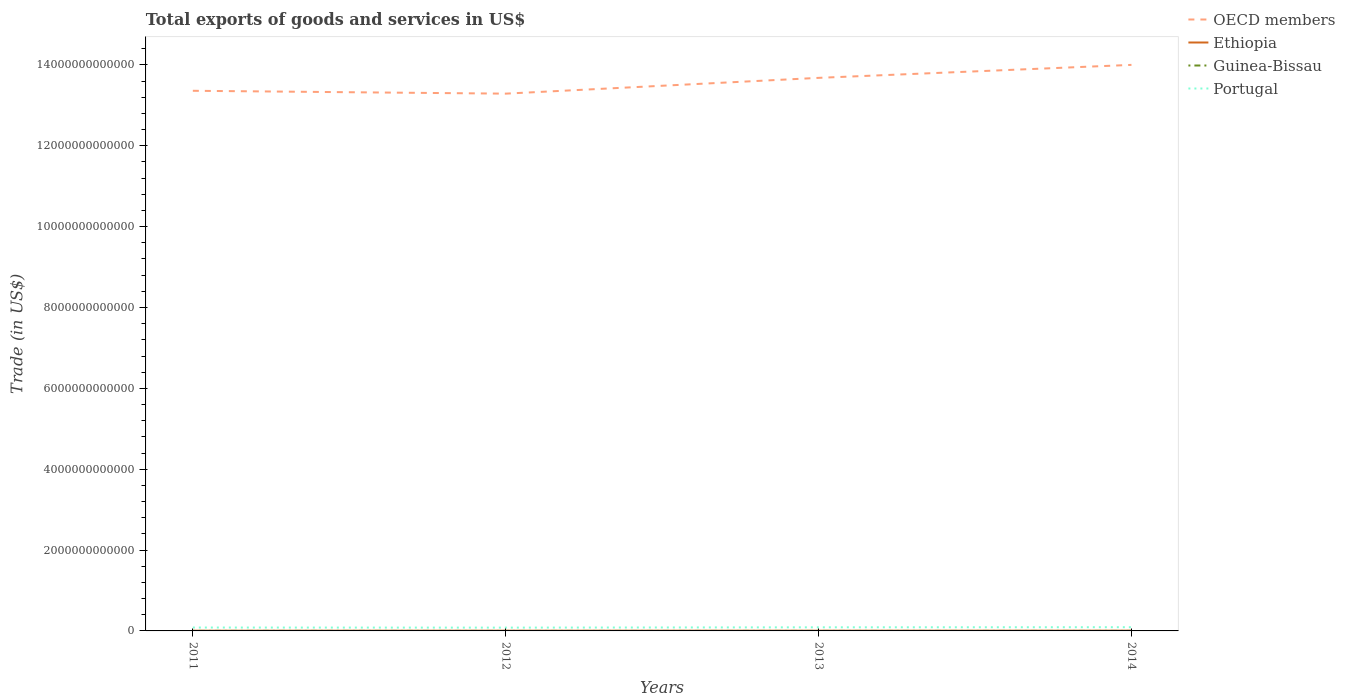Does the line corresponding to OECD members intersect with the line corresponding to Ethiopia?
Your response must be concise. No. Across all years, what is the maximum total exports of goods and services in Portugal?
Offer a terse response. 8.16e+1. What is the total total exports of goods and services in Guinea-Bissau in the graph?
Offer a very short reply. -2.21e+07. What is the difference between the highest and the second highest total exports of goods and services in Ethiopia?
Your answer should be very brief. 1.14e+09. How many lines are there?
Your response must be concise. 4. How many years are there in the graph?
Your answer should be very brief. 4. What is the difference between two consecutive major ticks on the Y-axis?
Make the answer very short. 2.00e+12. Are the values on the major ticks of Y-axis written in scientific E-notation?
Ensure brevity in your answer.  No. Does the graph contain any zero values?
Your answer should be compact. No. Where does the legend appear in the graph?
Your answer should be very brief. Top right. How are the legend labels stacked?
Offer a terse response. Vertical. What is the title of the graph?
Your answer should be compact. Total exports of goods and services in US$. What is the label or title of the Y-axis?
Provide a succinct answer. Trade (in US$). What is the Trade (in US$) in OECD members in 2011?
Give a very brief answer. 1.34e+13. What is the Trade (in US$) in Ethiopia in 2011?
Your answer should be very brief. 5.33e+09. What is the Trade (in US$) of Guinea-Bissau in 2011?
Provide a succinct answer. 2.96e+08. What is the Trade (in US$) of Portugal in 2011?
Ensure brevity in your answer.  8.40e+1. What is the Trade (in US$) of OECD members in 2012?
Your answer should be very brief. 1.33e+13. What is the Trade (in US$) in Ethiopia in 2012?
Offer a very short reply. 5.96e+09. What is the Trade (in US$) in Guinea-Bissau in 2012?
Your response must be concise. 1.43e+08. What is the Trade (in US$) of Portugal in 2012?
Your answer should be very brief. 8.16e+1. What is the Trade (in US$) in OECD members in 2013?
Your answer should be very brief. 1.37e+13. What is the Trade (in US$) in Ethiopia in 2013?
Provide a succinct answer. 5.95e+09. What is the Trade (in US$) of Guinea-Bissau in 2013?
Your response must be concise. 1.65e+08. What is the Trade (in US$) of Portugal in 2013?
Provide a succinct answer. 8.93e+1. What is the Trade (in US$) in OECD members in 2014?
Offer a very short reply. 1.40e+13. What is the Trade (in US$) in Ethiopia in 2014?
Offer a very short reply. 6.47e+09. What is the Trade (in US$) in Guinea-Bissau in 2014?
Your answer should be compact. 1.68e+08. What is the Trade (in US$) in Portugal in 2014?
Provide a succinct answer. 9.21e+1. Across all years, what is the maximum Trade (in US$) in OECD members?
Keep it short and to the point. 1.40e+13. Across all years, what is the maximum Trade (in US$) in Ethiopia?
Your answer should be compact. 6.47e+09. Across all years, what is the maximum Trade (in US$) in Guinea-Bissau?
Give a very brief answer. 2.96e+08. Across all years, what is the maximum Trade (in US$) of Portugal?
Offer a very short reply. 9.21e+1. Across all years, what is the minimum Trade (in US$) of OECD members?
Your response must be concise. 1.33e+13. Across all years, what is the minimum Trade (in US$) of Ethiopia?
Offer a very short reply. 5.33e+09. Across all years, what is the minimum Trade (in US$) in Guinea-Bissau?
Give a very brief answer. 1.43e+08. Across all years, what is the minimum Trade (in US$) of Portugal?
Your answer should be compact. 8.16e+1. What is the total Trade (in US$) in OECD members in the graph?
Offer a very short reply. 5.43e+13. What is the total Trade (in US$) of Ethiopia in the graph?
Keep it short and to the point. 2.37e+1. What is the total Trade (in US$) of Guinea-Bissau in the graph?
Keep it short and to the point. 7.73e+08. What is the total Trade (in US$) in Portugal in the graph?
Offer a terse response. 3.47e+11. What is the difference between the Trade (in US$) of OECD members in 2011 and that in 2012?
Keep it short and to the point. 7.06e+1. What is the difference between the Trade (in US$) of Ethiopia in 2011 and that in 2012?
Your answer should be very brief. -6.31e+08. What is the difference between the Trade (in US$) in Guinea-Bissau in 2011 and that in 2012?
Your response must be concise. 1.53e+08. What is the difference between the Trade (in US$) of Portugal in 2011 and that in 2012?
Your answer should be very brief. 2.38e+09. What is the difference between the Trade (in US$) in OECD members in 2011 and that in 2013?
Ensure brevity in your answer.  -3.20e+11. What is the difference between the Trade (in US$) of Ethiopia in 2011 and that in 2013?
Provide a succinct answer. -6.17e+08. What is the difference between the Trade (in US$) of Guinea-Bissau in 2011 and that in 2013?
Provide a succinct answer. 1.30e+08. What is the difference between the Trade (in US$) in Portugal in 2011 and that in 2013?
Keep it short and to the point. -5.36e+09. What is the difference between the Trade (in US$) in OECD members in 2011 and that in 2014?
Your answer should be compact. -6.41e+11. What is the difference between the Trade (in US$) of Ethiopia in 2011 and that in 2014?
Give a very brief answer. -1.14e+09. What is the difference between the Trade (in US$) of Guinea-Bissau in 2011 and that in 2014?
Keep it short and to the point. 1.28e+08. What is the difference between the Trade (in US$) in Portugal in 2011 and that in 2014?
Ensure brevity in your answer.  -8.18e+09. What is the difference between the Trade (in US$) in OECD members in 2012 and that in 2013?
Provide a succinct answer. -3.91e+11. What is the difference between the Trade (in US$) of Ethiopia in 2012 and that in 2013?
Ensure brevity in your answer.  1.43e+07. What is the difference between the Trade (in US$) of Guinea-Bissau in 2012 and that in 2013?
Provide a succinct answer. -2.21e+07. What is the difference between the Trade (in US$) of Portugal in 2012 and that in 2013?
Ensure brevity in your answer.  -7.74e+09. What is the difference between the Trade (in US$) of OECD members in 2012 and that in 2014?
Your response must be concise. -7.12e+11. What is the difference between the Trade (in US$) of Ethiopia in 2012 and that in 2014?
Provide a short and direct response. -5.11e+08. What is the difference between the Trade (in US$) in Guinea-Bissau in 2012 and that in 2014?
Offer a terse response. -2.49e+07. What is the difference between the Trade (in US$) of Portugal in 2012 and that in 2014?
Your answer should be very brief. -1.06e+1. What is the difference between the Trade (in US$) in OECD members in 2013 and that in 2014?
Your response must be concise. -3.21e+11. What is the difference between the Trade (in US$) in Ethiopia in 2013 and that in 2014?
Your answer should be very brief. -5.26e+08. What is the difference between the Trade (in US$) of Guinea-Bissau in 2013 and that in 2014?
Provide a short and direct response. -2.83e+06. What is the difference between the Trade (in US$) of Portugal in 2013 and that in 2014?
Provide a succinct answer. -2.81e+09. What is the difference between the Trade (in US$) of OECD members in 2011 and the Trade (in US$) of Ethiopia in 2012?
Give a very brief answer. 1.34e+13. What is the difference between the Trade (in US$) in OECD members in 2011 and the Trade (in US$) in Guinea-Bissau in 2012?
Keep it short and to the point. 1.34e+13. What is the difference between the Trade (in US$) in OECD members in 2011 and the Trade (in US$) in Portugal in 2012?
Your answer should be compact. 1.33e+13. What is the difference between the Trade (in US$) of Ethiopia in 2011 and the Trade (in US$) of Guinea-Bissau in 2012?
Give a very brief answer. 5.19e+09. What is the difference between the Trade (in US$) in Ethiopia in 2011 and the Trade (in US$) in Portugal in 2012?
Ensure brevity in your answer.  -7.63e+1. What is the difference between the Trade (in US$) in Guinea-Bissau in 2011 and the Trade (in US$) in Portugal in 2012?
Give a very brief answer. -8.13e+1. What is the difference between the Trade (in US$) of OECD members in 2011 and the Trade (in US$) of Ethiopia in 2013?
Make the answer very short. 1.34e+13. What is the difference between the Trade (in US$) of OECD members in 2011 and the Trade (in US$) of Guinea-Bissau in 2013?
Ensure brevity in your answer.  1.34e+13. What is the difference between the Trade (in US$) in OECD members in 2011 and the Trade (in US$) in Portugal in 2013?
Make the answer very short. 1.33e+13. What is the difference between the Trade (in US$) of Ethiopia in 2011 and the Trade (in US$) of Guinea-Bissau in 2013?
Your answer should be compact. 5.17e+09. What is the difference between the Trade (in US$) in Ethiopia in 2011 and the Trade (in US$) in Portugal in 2013?
Provide a succinct answer. -8.40e+1. What is the difference between the Trade (in US$) in Guinea-Bissau in 2011 and the Trade (in US$) in Portugal in 2013?
Your response must be concise. -8.90e+1. What is the difference between the Trade (in US$) of OECD members in 2011 and the Trade (in US$) of Ethiopia in 2014?
Provide a short and direct response. 1.34e+13. What is the difference between the Trade (in US$) of OECD members in 2011 and the Trade (in US$) of Guinea-Bissau in 2014?
Provide a short and direct response. 1.34e+13. What is the difference between the Trade (in US$) of OECD members in 2011 and the Trade (in US$) of Portugal in 2014?
Ensure brevity in your answer.  1.33e+13. What is the difference between the Trade (in US$) in Ethiopia in 2011 and the Trade (in US$) in Guinea-Bissau in 2014?
Your response must be concise. 5.16e+09. What is the difference between the Trade (in US$) of Ethiopia in 2011 and the Trade (in US$) of Portugal in 2014?
Your answer should be compact. -8.68e+1. What is the difference between the Trade (in US$) of Guinea-Bissau in 2011 and the Trade (in US$) of Portugal in 2014?
Your response must be concise. -9.19e+1. What is the difference between the Trade (in US$) in OECD members in 2012 and the Trade (in US$) in Ethiopia in 2013?
Provide a succinct answer. 1.33e+13. What is the difference between the Trade (in US$) in OECD members in 2012 and the Trade (in US$) in Guinea-Bissau in 2013?
Make the answer very short. 1.33e+13. What is the difference between the Trade (in US$) in OECD members in 2012 and the Trade (in US$) in Portugal in 2013?
Provide a succinct answer. 1.32e+13. What is the difference between the Trade (in US$) in Ethiopia in 2012 and the Trade (in US$) in Guinea-Bissau in 2013?
Your answer should be very brief. 5.80e+09. What is the difference between the Trade (in US$) of Ethiopia in 2012 and the Trade (in US$) of Portugal in 2013?
Ensure brevity in your answer.  -8.34e+1. What is the difference between the Trade (in US$) of Guinea-Bissau in 2012 and the Trade (in US$) of Portugal in 2013?
Your answer should be compact. -8.92e+1. What is the difference between the Trade (in US$) in OECD members in 2012 and the Trade (in US$) in Ethiopia in 2014?
Offer a terse response. 1.33e+13. What is the difference between the Trade (in US$) of OECD members in 2012 and the Trade (in US$) of Guinea-Bissau in 2014?
Your answer should be very brief. 1.33e+13. What is the difference between the Trade (in US$) in OECD members in 2012 and the Trade (in US$) in Portugal in 2014?
Make the answer very short. 1.32e+13. What is the difference between the Trade (in US$) in Ethiopia in 2012 and the Trade (in US$) in Guinea-Bissau in 2014?
Your response must be concise. 5.79e+09. What is the difference between the Trade (in US$) of Ethiopia in 2012 and the Trade (in US$) of Portugal in 2014?
Keep it short and to the point. -8.62e+1. What is the difference between the Trade (in US$) in Guinea-Bissau in 2012 and the Trade (in US$) in Portugal in 2014?
Your response must be concise. -9.20e+1. What is the difference between the Trade (in US$) in OECD members in 2013 and the Trade (in US$) in Ethiopia in 2014?
Make the answer very short. 1.37e+13. What is the difference between the Trade (in US$) in OECD members in 2013 and the Trade (in US$) in Guinea-Bissau in 2014?
Keep it short and to the point. 1.37e+13. What is the difference between the Trade (in US$) of OECD members in 2013 and the Trade (in US$) of Portugal in 2014?
Ensure brevity in your answer.  1.36e+13. What is the difference between the Trade (in US$) in Ethiopia in 2013 and the Trade (in US$) in Guinea-Bissau in 2014?
Make the answer very short. 5.78e+09. What is the difference between the Trade (in US$) of Ethiopia in 2013 and the Trade (in US$) of Portugal in 2014?
Your answer should be very brief. -8.62e+1. What is the difference between the Trade (in US$) of Guinea-Bissau in 2013 and the Trade (in US$) of Portugal in 2014?
Provide a succinct answer. -9.20e+1. What is the average Trade (in US$) in OECD members per year?
Give a very brief answer. 1.36e+13. What is the average Trade (in US$) in Ethiopia per year?
Make the answer very short. 5.93e+09. What is the average Trade (in US$) of Guinea-Bissau per year?
Provide a succinct answer. 1.93e+08. What is the average Trade (in US$) of Portugal per year?
Your answer should be compact. 8.68e+1. In the year 2011, what is the difference between the Trade (in US$) in OECD members and Trade (in US$) in Ethiopia?
Give a very brief answer. 1.34e+13. In the year 2011, what is the difference between the Trade (in US$) in OECD members and Trade (in US$) in Guinea-Bissau?
Your answer should be very brief. 1.34e+13. In the year 2011, what is the difference between the Trade (in US$) in OECD members and Trade (in US$) in Portugal?
Provide a succinct answer. 1.33e+13. In the year 2011, what is the difference between the Trade (in US$) of Ethiopia and Trade (in US$) of Guinea-Bissau?
Make the answer very short. 5.04e+09. In the year 2011, what is the difference between the Trade (in US$) of Ethiopia and Trade (in US$) of Portugal?
Give a very brief answer. -7.86e+1. In the year 2011, what is the difference between the Trade (in US$) in Guinea-Bissau and Trade (in US$) in Portugal?
Provide a succinct answer. -8.37e+1. In the year 2012, what is the difference between the Trade (in US$) of OECD members and Trade (in US$) of Ethiopia?
Provide a succinct answer. 1.33e+13. In the year 2012, what is the difference between the Trade (in US$) in OECD members and Trade (in US$) in Guinea-Bissau?
Ensure brevity in your answer.  1.33e+13. In the year 2012, what is the difference between the Trade (in US$) of OECD members and Trade (in US$) of Portugal?
Give a very brief answer. 1.32e+13. In the year 2012, what is the difference between the Trade (in US$) of Ethiopia and Trade (in US$) of Guinea-Bissau?
Keep it short and to the point. 5.82e+09. In the year 2012, what is the difference between the Trade (in US$) in Ethiopia and Trade (in US$) in Portugal?
Offer a very short reply. -7.56e+1. In the year 2012, what is the difference between the Trade (in US$) in Guinea-Bissau and Trade (in US$) in Portugal?
Ensure brevity in your answer.  -8.15e+1. In the year 2013, what is the difference between the Trade (in US$) of OECD members and Trade (in US$) of Ethiopia?
Give a very brief answer. 1.37e+13. In the year 2013, what is the difference between the Trade (in US$) of OECD members and Trade (in US$) of Guinea-Bissau?
Your response must be concise. 1.37e+13. In the year 2013, what is the difference between the Trade (in US$) in OECD members and Trade (in US$) in Portugal?
Keep it short and to the point. 1.36e+13. In the year 2013, what is the difference between the Trade (in US$) of Ethiopia and Trade (in US$) of Guinea-Bissau?
Provide a succinct answer. 5.78e+09. In the year 2013, what is the difference between the Trade (in US$) in Ethiopia and Trade (in US$) in Portugal?
Your answer should be very brief. -8.34e+1. In the year 2013, what is the difference between the Trade (in US$) of Guinea-Bissau and Trade (in US$) of Portugal?
Your answer should be very brief. -8.92e+1. In the year 2014, what is the difference between the Trade (in US$) of OECD members and Trade (in US$) of Ethiopia?
Provide a short and direct response. 1.40e+13. In the year 2014, what is the difference between the Trade (in US$) of OECD members and Trade (in US$) of Guinea-Bissau?
Provide a succinct answer. 1.40e+13. In the year 2014, what is the difference between the Trade (in US$) of OECD members and Trade (in US$) of Portugal?
Your answer should be compact. 1.39e+13. In the year 2014, what is the difference between the Trade (in US$) in Ethiopia and Trade (in US$) in Guinea-Bissau?
Your answer should be very brief. 6.31e+09. In the year 2014, what is the difference between the Trade (in US$) of Ethiopia and Trade (in US$) of Portugal?
Keep it short and to the point. -8.57e+1. In the year 2014, what is the difference between the Trade (in US$) of Guinea-Bissau and Trade (in US$) of Portugal?
Offer a terse response. -9.20e+1. What is the ratio of the Trade (in US$) of Ethiopia in 2011 to that in 2012?
Your response must be concise. 0.89. What is the ratio of the Trade (in US$) of Guinea-Bissau in 2011 to that in 2012?
Provide a short and direct response. 2.06. What is the ratio of the Trade (in US$) in Portugal in 2011 to that in 2012?
Provide a short and direct response. 1.03. What is the ratio of the Trade (in US$) in OECD members in 2011 to that in 2013?
Your response must be concise. 0.98. What is the ratio of the Trade (in US$) in Ethiopia in 2011 to that in 2013?
Your answer should be compact. 0.9. What is the ratio of the Trade (in US$) of Guinea-Bissau in 2011 to that in 2013?
Offer a terse response. 1.79. What is the ratio of the Trade (in US$) of OECD members in 2011 to that in 2014?
Keep it short and to the point. 0.95. What is the ratio of the Trade (in US$) of Ethiopia in 2011 to that in 2014?
Offer a very short reply. 0.82. What is the ratio of the Trade (in US$) in Guinea-Bissau in 2011 to that in 2014?
Make the answer very short. 1.76. What is the ratio of the Trade (in US$) in Portugal in 2011 to that in 2014?
Give a very brief answer. 0.91. What is the ratio of the Trade (in US$) in OECD members in 2012 to that in 2013?
Provide a succinct answer. 0.97. What is the ratio of the Trade (in US$) in Ethiopia in 2012 to that in 2013?
Provide a succinct answer. 1. What is the ratio of the Trade (in US$) of Guinea-Bissau in 2012 to that in 2013?
Give a very brief answer. 0.87. What is the ratio of the Trade (in US$) in Portugal in 2012 to that in 2013?
Your answer should be compact. 0.91. What is the ratio of the Trade (in US$) of OECD members in 2012 to that in 2014?
Offer a very short reply. 0.95. What is the ratio of the Trade (in US$) of Ethiopia in 2012 to that in 2014?
Keep it short and to the point. 0.92. What is the ratio of the Trade (in US$) of Guinea-Bissau in 2012 to that in 2014?
Your answer should be compact. 0.85. What is the ratio of the Trade (in US$) in Portugal in 2012 to that in 2014?
Offer a very short reply. 0.89. What is the ratio of the Trade (in US$) in OECD members in 2013 to that in 2014?
Give a very brief answer. 0.98. What is the ratio of the Trade (in US$) of Ethiopia in 2013 to that in 2014?
Keep it short and to the point. 0.92. What is the ratio of the Trade (in US$) in Guinea-Bissau in 2013 to that in 2014?
Your answer should be compact. 0.98. What is the ratio of the Trade (in US$) in Portugal in 2013 to that in 2014?
Offer a very short reply. 0.97. What is the difference between the highest and the second highest Trade (in US$) of OECD members?
Provide a succinct answer. 3.21e+11. What is the difference between the highest and the second highest Trade (in US$) in Ethiopia?
Offer a terse response. 5.11e+08. What is the difference between the highest and the second highest Trade (in US$) of Guinea-Bissau?
Ensure brevity in your answer.  1.28e+08. What is the difference between the highest and the second highest Trade (in US$) in Portugal?
Make the answer very short. 2.81e+09. What is the difference between the highest and the lowest Trade (in US$) in OECD members?
Your answer should be compact. 7.12e+11. What is the difference between the highest and the lowest Trade (in US$) in Ethiopia?
Offer a very short reply. 1.14e+09. What is the difference between the highest and the lowest Trade (in US$) in Guinea-Bissau?
Your answer should be very brief. 1.53e+08. What is the difference between the highest and the lowest Trade (in US$) in Portugal?
Give a very brief answer. 1.06e+1. 